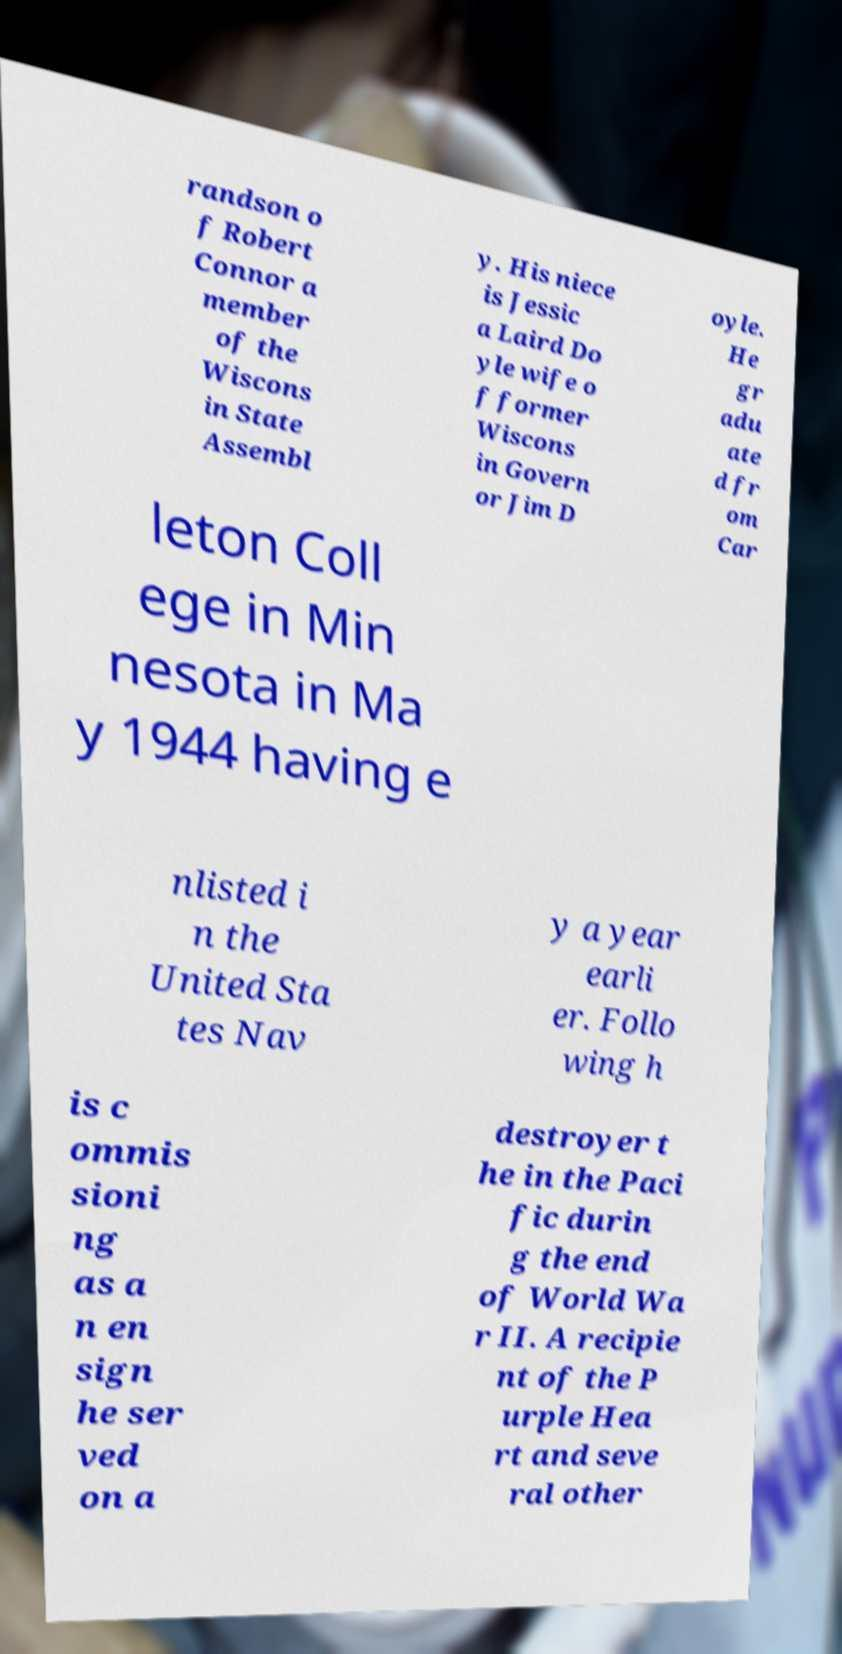There's text embedded in this image that I need extracted. Can you transcribe it verbatim? randson o f Robert Connor a member of the Wiscons in State Assembl y. His niece is Jessic a Laird Do yle wife o f former Wiscons in Govern or Jim D oyle. He gr adu ate d fr om Car leton Coll ege in Min nesota in Ma y 1944 having e nlisted i n the United Sta tes Nav y a year earli er. Follo wing h is c ommis sioni ng as a n en sign he ser ved on a destroyer t he in the Paci fic durin g the end of World Wa r II. A recipie nt of the P urple Hea rt and seve ral other 